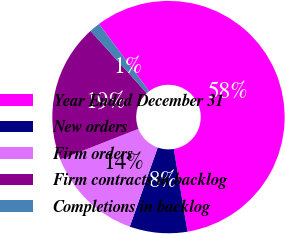<chart> <loc_0><loc_0><loc_500><loc_500><pie_chart><fcel>Year Ended December 31<fcel>New orders<fcel>Firm orders<fcel>Firm contracts in backlog<fcel>Completions in backlog<nl><fcel>57.59%<fcel>8.03%<fcel>13.64%<fcel>19.25%<fcel>1.49%<nl></chart> 